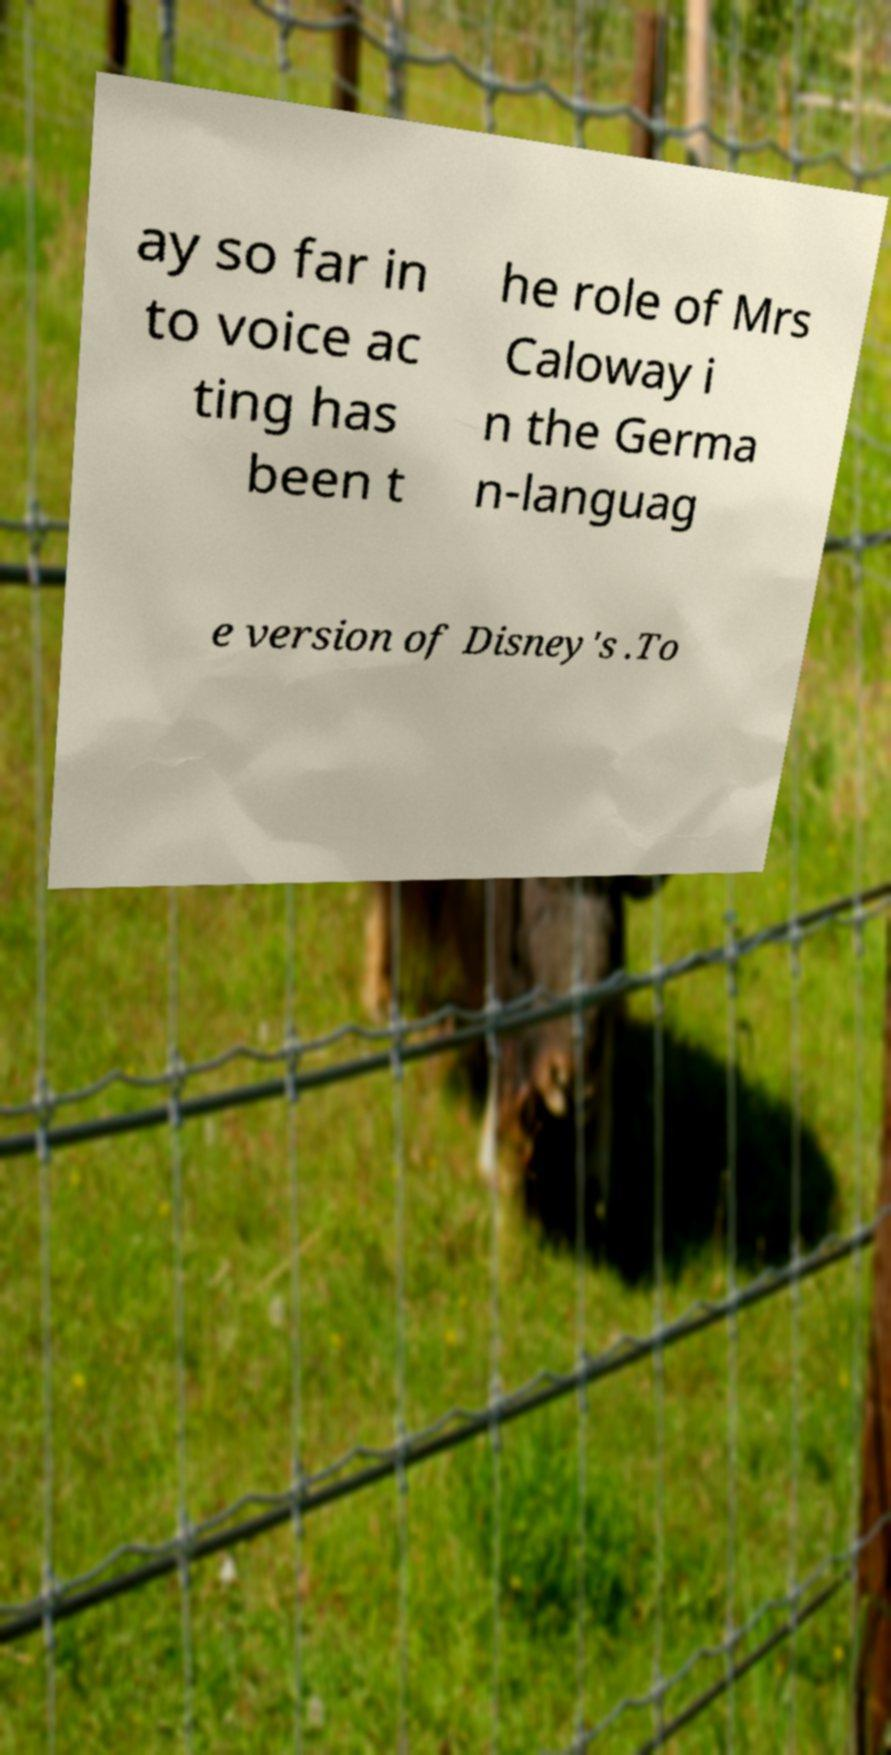Can you read and provide the text displayed in the image?This photo seems to have some interesting text. Can you extract and type it out for me? ay so far in to voice ac ting has been t he role of Mrs Caloway i n the Germa n-languag e version of Disney's .To 